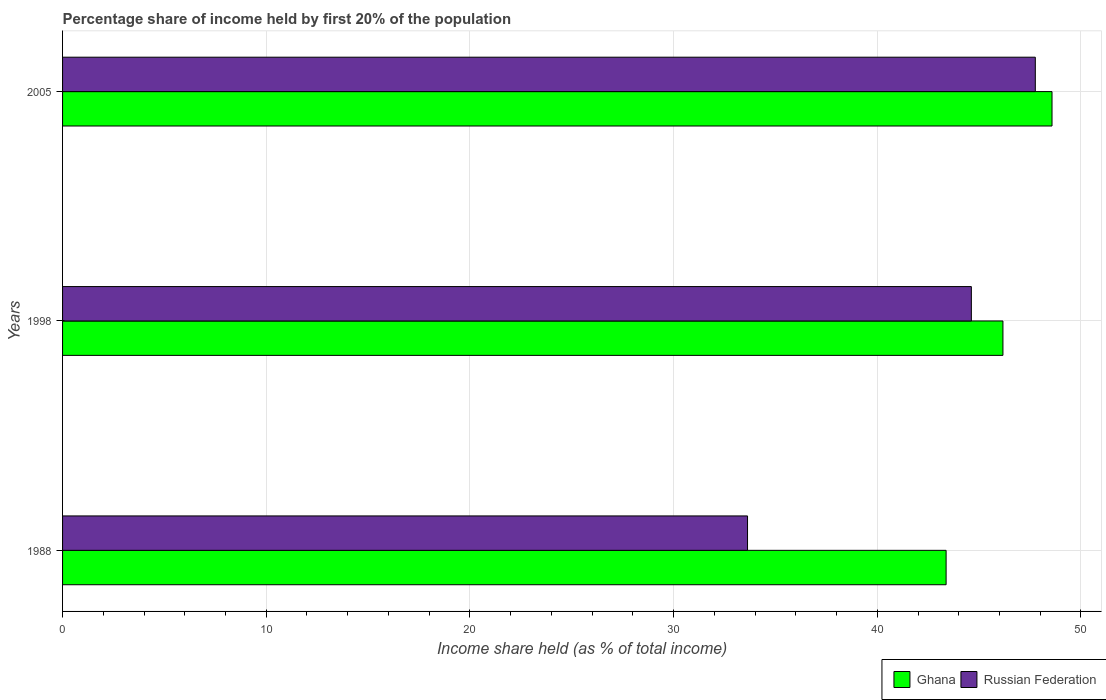Are the number of bars per tick equal to the number of legend labels?
Make the answer very short. Yes. Are the number of bars on each tick of the Y-axis equal?
Provide a short and direct response. Yes. How many bars are there on the 3rd tick from the top?
Your answer should be very brief. 2. What is the share of income held by first 20% of the population in Ghana in 1988?
Offer a very short reply. 43.38. Across all years, what is the maximum share of income held by first 20% of the population in Russian Federation?
Offer a terse response. 47.76. Across all years, what is the minimum share of income held by first 20% of the population in Ghana?
Your response must be concise. 43.38. In which year was the share of income held by first 20% of the population in Ghana minimum?
Offer a terse response. 1988. What is the total share of income held by first 20% of the population in Russian Federation in the graph?
Offer a very short reply. 126.01. What is the difference between the share of income held by first 20% of the population in Russian Federation in 1998 and that in 2005?
Offer a very short reply. -3.14. What is the difference between the share of income held by first 20% of the population in Ghana in 2005 and the share of income held by first 20% of the population in Russian Federation in 1998?
Your response must be concise. 3.96. What is the average share of income held by first 20% of the population in Russian Federation per year?
Give a very brief answer. 42. In the year 1998, what is the difference between the share of income held by first 20% of the population in Ghana and share of income held by first 20% of the population in Russian Federation?
Give a very brief answer. 1.55. In how many years, is the share of income held by first 20% of the population in Russian Federation greater than 38 %?
Your answer should be compact. 2. What is the ratio of the share of income held by first 20% of the population in Ghana in 1998 to that in 2005?
Your answer should be very brief. 0.95. What is the difference between the highest and the second highest share of income held by first 20% of the population in Russian Federation?
Your answer should be very brief. 3.14. What is the difference between the highest and the lowest share of income held by first 20% of the population in Russian Federation?
Provide a short and direct response. 14.13. In how many years, is the share of income held by first 20% of the population in Ghana greater than the average share of income held by first 20% of the population in Ghana taken over all years?
Your response must be concise. 2. Is the sum of the share of income held by first 20% of the population in Ghana in 1988 and 1998 greater than the maximum share of income held by first 20% of the population in Russian Federation across all years?
Offer a very short reply. Yes. What does the 2nd bar from the top in 1998 represents?
Keep it short and to the point. Ghana. What does the 1st bar from the bottom in 1988 represents?
Offer a terse response. Ghana. How many bars are there?
Your answer should be very brief. 6. Are all the bars in the graph horizontal?
Your answer should be very brief. Yes. How many years are there in the graph?
Your answer should be compact. 3. What is the difference between two consecutive major ticks on the X-axis?
Ensure brevity in your answer.  10. Where does the legend appear in the graph?
Keep it short and to the point. Bottom right. How many legend labels are there?
Provide a short and direct response. 2. What is the title of the graph?
Give a very brief answer. Percentage share of income held by first 20% of the population. What is the label or title of the X-axis?
Offer a terse response. Income share held (as % of total income). What is the label or title of the Y-axis?
Provide a short and direct response. Years. What is the Income share held (as % of total income) in Ghana in 1988?
Ensure brevity in your answer.  43.38. What is the Income share held (as % of total income) of Russian Federation in 1988?
Your response must be concise. 33.63. What is the Income share held (as % of total income) in Ghana in 1998?
Make the answer very short. 46.17. What is the Income share held (as % of total income) of Russian Federation in 1998?
Provide a short and direct response. 44.62. What is the Income share held (as % of total income) in Ghana in 2005?
Your answer should be very brief. 48.58. What is the Income share held (as % of total income) in Russian Federation in 2005?
Offer a terse response. 47.76. Across all years, what is the maximum Income share held (as % of total income) in Ghana?
Make the answer very short. 48.58. Across all years, what is the maximum Income share held (as % of total income) in Russian Federation?
Provide a succinct answer. 47.76. Across all years, what is the minimum Income share held (as % of total income) in Ghana?
Provide a short and direct response. 43.38. Across all years, what is the minimum Income share held (as % of total income) in Russian Federation?
Make the answer very short. 33.63. What is the total Income share held (as % of total income) of Ghana in the graph?
Keep it short and to the point. 138.13. What is the total Income share held (as % of total income) of Russian Federation in the graph?
Your answer should be very brief. 126.01. What is the difference between the Income share held (as % of total income) in Ghana in 1988 and that in 1998?
Offer a very short reply. -2.79. What is the difference between the Income share held (as % of total income) in Russian Federation in 1988 and that in 1998?
Provide a succinct answer. -10.99. What is the difference between the Income share held (as % of total income) in Russian Federation in 1988 and that in 2005?
Provide a succinct answer. -14.13. What is the difference between the Income share held (as % of total income) in Ghana in 1998 and that in 2005?
Make the answer very short. -2.41. What is the difference between the Income share held (as % of total income) in Russian Federation in 1998 and that in 2005?
Ensure brevity in your answer.  -3.14. What is the difference between the Income share held (as % of total income) in Ghana in 1988 and the Income share held (as % of total income) in Russian Federation in 1998?
Offer a very short reply. -1.24. What is the difference between the Income share held (as % of total income) of Ghana in 1988 and the Income share held (as % of total income) of Russian Federation in 2005?
Give a very brief answer. -4.38. What is the difference between the Income share held (as % of total income) in Ghana in 1998 and the Income share held (as % of total income) in Russian Federation in 2005?
Make the answer very short. -1.59. What is the average Income share held (as % of total income) in Ghana per year?
Offer a terse response. 46.04. What is the average Income share held (as % of total income) in Russian Federation per year?
Ensure brevity in your answer.  42. In the year 1988, what is the difference between the Income share held (as % of total income) in Ghana and Income share held (as % of total income) in Russian Federation?
Ensure brevity in your answer.  9.75. In the year 1998, what is the difference between the Income share held (as % of total income) in Ghana and Income share held (as % of total income) in Russian Federation?
Provide a short and direct response. 1.55. In the year 2005, what is the difference between the Income share held (as % of total income) of Ghana and Income share held (as % of total income) of Russian Federation?
Your response must be concise. 0.82. What is the ratio of the Income share held (as % of total income) in Ghana in 1988 to that in 1998?
Give a very brief answer. 0.94. What is the ratio of the Income share held (as % of total income) of Russian Federation in 1988 to that in 1998?
Offer a very short reply. 0.75. What is the ratio of the Income share held (as % of total income) of Ghana in 1988 to that in 2005?
Your response must be concise. 0.89. What is the ratio of the Income share held (as % of total income) of Russian Federation in 1988 to that in 2005?
Your answer should be very brief. 0.7. What is the ratio of the Income share held (as % of total income) of Ghana in 1998 to that in 2005?
Offer a terse response. 0.95. What is the ratio of the Income share held (as % of total income) of Russian Federation in 1998 to that in 2005?
Your response must be concise. 0.93. What is the difference between the highest and the second highest Income share held (as % of total income) in Ghana?
Make the answer very short. 2.41. What is the difference between the highest and the second highest Income share held (as % of total income) in Russian Federation?
Make the answer very short. 3.14. What is the difference between the highest and the lowest Income share held (as % of total income) in Ghana?
Offer a very short reply. 5.2. What is the difference between the highest and the lowest Income share held (as % of total income) of Russian Federation?
Offer a very short reply. 14.13. 